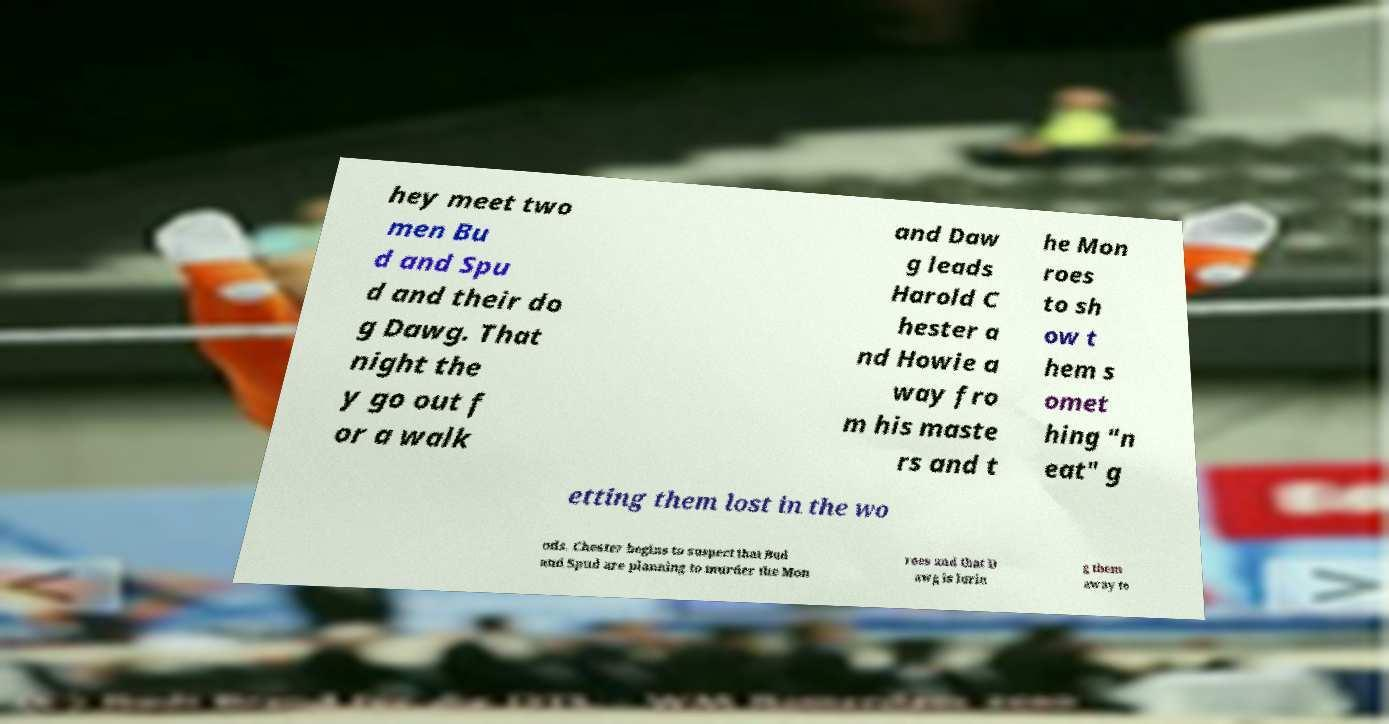What messages or text are displayed in this image? I need them in a readable, typed format. hey meet two men Bu d and Spu d and their do g Dawg. That night the y go out f or a walk and Daw g leads Harold C hester a nd Howie a way fro m his maste rs and t he Mon roes to sh ow t hem s omet hing "n eat" g etting them lost in the wo ods. Chester begins to suspect that Bud and Spud are planning to murder the Mon roes and that D awg is lurin g them away to 